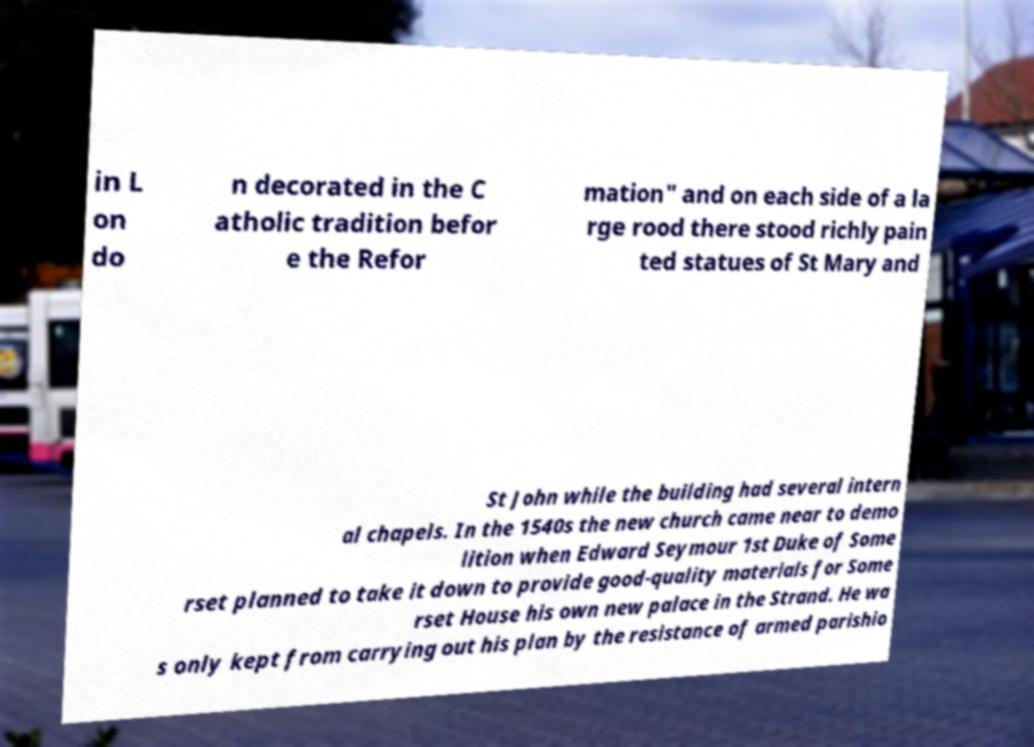There's text embedded in this image that I need extracted. Can you transcribe it verbatim? in L on do n decorated in the C atholic tradition befor e the Refor mation" and on each side of a la rge rood there stood richly pain ted statues of St Mary and St John while the building had several intern al chapels. In the 1540s the new church came near to demo lition when Edward Seymour 1st Duke of Some rset planned to take it down to provide good-quality materials for Some rset House his own new palace in the Strand. He wa s only kept from carrying out his plan by the resistance of armed parishio 